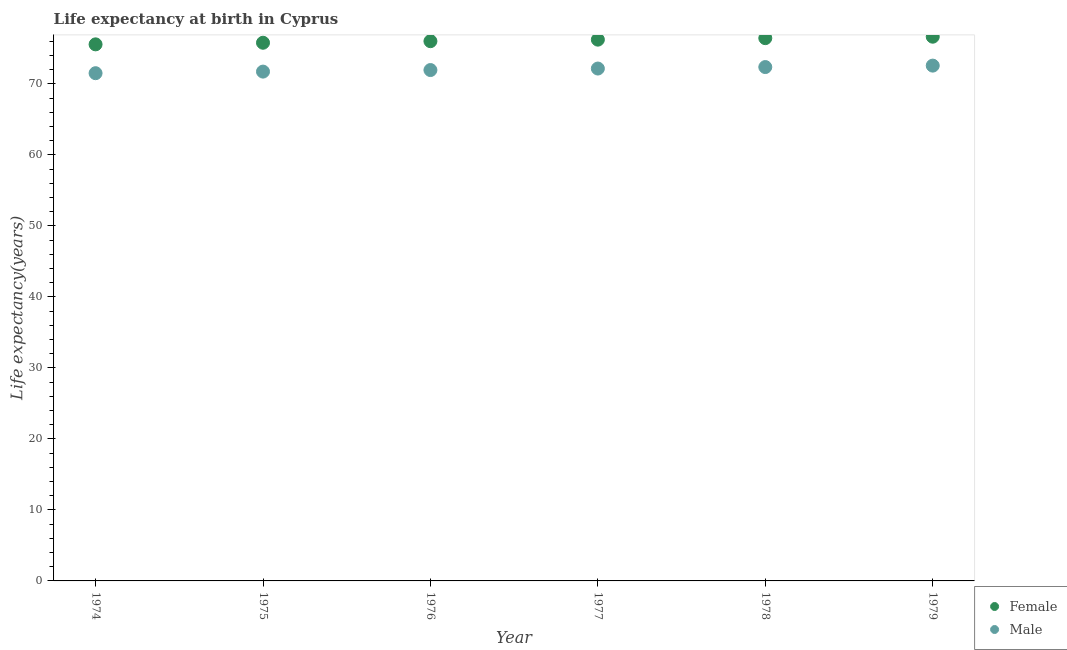What is the life expectancy(male) in 1977?
Give a very brief answer. 72.16. Across all years, what is the maximum life expectancy(male)?
Make the answer very short. 72.57. Across all years, what is the minimum life expectancy(female)?
Ensure brevity in your answer.  75.57. In which year was the life expectancy(female) maximum?
Offer a terse response. 1979. In which year was the life expectancy(male) minimum?
Make the answer very short. 1974. What is the total life expectancy(male) in the graph?
Offer a very short reply. 432.28. What is the difference between the life expectancy(male) in 1974 and that in 1978?
Offer a terse response. -0.86. What is the difference between the life expectancy(female) in 1975 and the life expectancy(male) in 1976?
Offer a terse response. 3.84. What is the average life expectancy(male) per year?
Give a very brief answer. 72.05. In the year 1978, what is the difference between the life expectancy(male) and life expectancy(female)?
Offer a very short reply. -4.07. In how many years, is the life expectancy(female) greater than 6 years?
Give a very brief answer. 6. What is the ratio of the life expectancy(female) in 1977 to that in 1978?
Keep it short and to the point. 1. Is the life expectancy(female) in 1977 less than that in 1979?
Give a very brief answer. Yes. Is the difference between the life expectancy(male) in 1974 and 1978 greater than the difference between the life expectancy(female) in 1974 and 1978?
Provide a short and direct response. Yes. What is the difference between the highest and the second highest life expectancy(female)?
Provide a short and direct response. 0.2. What is the difference between the highest and the lowest life expectancy(male)?
Your response must be concise. 1.07. In how many years, is the life expectancy(female) greater than the average life expectancy(female) taken over all years?
Give a very brief answer. 3. Is the sum of the life expectancy(female) in 1977 and 1978 greater than the maximum life expectancy(male) across all years?
Provide a succinct answer. Yes. What is the difference between two consecutive major ticks on the Y-axis?
Keep it short and to the point. 10. Are the values on the major ticks of Y-axis written in scientific E-notation?
Give a very brief answer. No. Does the graph contain any zero values?
Make the answer very short. No. How many legend labels are there?
Offer a terse response. 2. How are the legend labels stacked?
Your response must be concise. Vertical. What is the title of the graph?
Provide a short and direct response. Life expectancy at birth in Cyprus. Does "Secondary" appear as one of the legend labels in the graph?
Give a very brief answer. No. What is the label or title of the X-axis?
Keep it short and to the point. Year. What is the label or title of the Y-axis?
Keep it short and to the point. Life expectancy(years). What is the Life expectancy(years) in Female in 1974?
Your answer should be compact. 75.57. What is the Life expectancy(years) in Male in 1974?
Your response must be concise. 71.5. What is the Life expectancy(years) of Female in 1975?
Make the answer very short. 75.79. What is the Life expectancy(years) in Male in 1975?
Your response must be concise. 71.73. What is the Life expectancy(years) of Female in 1976?
Your answer should be very brief. 76.01. What is the Life expectancy(years) of Male in 1976?
Offer a terse response. 71.95. What is the Life expectancy(years) in Female in 1977?
Make the answer very short. 76.23. What is the Life expectancy(years) in Male in 1977?
Your answer should be compact. 72.16. What is the Life expectancy(years) of Female in 1978?
Make the answer very short. 76.44. What is the Life expectancy(years) of Male in 1978?
Your response must be concise. 72.37. What is the Life expectancy(years) of Female in 1979?
Your answer should be very brief. 76.64. What is the Life expectancy(years) in Male in 1979?
Provide a succinct answer. 72.57. Across all years, what is the maximum Life expectancy(years) in Female?
Offer a very short reply. 76.64. Across all years, what is the maximum Life expectancy(years) of Male?
Offer a terse response. 72.57. Across all years, what is the minimum Life expectancy(years) of Female?
Ensure brevity in your answer.  75.57. Across all years, what is the minimum Life expectancy(years) in Male?
Provide a short and direct response. 71.5. What is the total Life expectancy(years) in Female in the graph?
Give a very brief answer. 456.68. What is the total Life expectancy(years) in Male in the graph?
Your response must be concise. 432.28. What is the difference between the Life expectancy(years) of Female in 1974 and that in 1975?
Keep it short and to the point. -0.23. What is the difference between the Life expectancy(years) of Male in 1974 and that in 1975?
Your answer should be compact. -0.22. What is the difference between the Life expectancy(years) in Female in 1974 and that in 1976?
Your answer should be compact. -0.45. What is the difference between the Life expectancy(years) of Male in 1974 and that in 1976?
Offer a terse response. -0.44. What is the difference between the Life expectancy(years) in Female in 1974 and that in 1977?
Offer a terse response. -0.66. What is the difference between the Life expectancy(years) in Male in 1974 and that in 1977?
Make the answer very short. -0.66. What is the difference between the Life expectancy(years) in Female in 1974 and that in 1978?
Provide a short and direct response. -0.87. What is the difference between the Life expectancy(years) in Male in 1974 and that in 1978?
Provide a short and direct response. -0.86. What is the difference between the Life expectancy(years) in Female in 1974 and that in 1979?
Ensure brevity in your answer.  -1.08. What is the difference between the Life expectancy(years) of Male in 1974 and that in 1979?
Offer a terse response. -1.07. What is the difference between the Life expectancy(years) of Female in 1975 and that in 1976?
Your answer should be compact. -0.22. What is the difference between the Life expectancy(years) in Male in 1975 and that in 1976?
Provide a succinct answer. -0.22. What is the difference between the Life expectancy(years) of Female in 1975 and that in 1977?
Offer a very short reply. -0.44. What is the difference between the Life expectancy(years) of Male in 1975 and that in 1977?
Provide a short and direct response. -0.43. What is the difference between the Life expectancy(years) in Female in 1975 and that in 1978?
Make the answer very short. -0.65. What is the difference between the Life expectancy(years) of Male in 1975 and that in 1978?
Offer a very short reply. -0.64. What is the difference between the Life expectancy(years) of Female in 1975 and that in 1979?
Ensure brevity in your answer.  -0.85. What is the difference between the Life expectancy(years) of Male in 1975 and that in 1979?
Make the answer very short. -0.84. What is the difference between the Life expectancy(years) in Female in 1976 and that in 1977?
Provide a short and direct response. -0.22. What is the difference between the Life expectancy(years) in Male in 1976 and that in 1977?
Make the answer very short. -0.21. What is the difference between the Life expectancy(years) in Female in 1976 and that in 1978?
Make the answer very short. -0.43. What is the difference between the Life expectancy(years) in Male in 1976 and that in 1978?
Offer a terse response. -0.42. What is the difference between the Life expectancy(years) of Female in 1976 and that in 1979?
Offer a very short reply. -0.63. What is the difference between the Life expectancy(years) of Male in 1976 and that in 1979?
Offer a terse response. -0.62. What is the difference between the Life expectancy(years) in Female in 1977 and that in 1978?
Ensure brevity in your answer.  -0.21. What is the difference between the Life expectancy(years) in Male in 1977 and that in 1978?
Give a very brief answer. -0.21. What is the difference between the Life expectancy(years) of Female in 1977 and that in 1979?
Keep it short and to the point. -0.41. What is the difference between the Life expectancy(years) of Male in 1977 and that in 1979?
Provide a short and direct response. -0.41. What is the difference between the Life expectancy(years) of Female in 1978 and that in 1979?
Offer a terse response. -0.2. What is the difference between the Life expectancy(years) of Male in 1978 and that in 1979?
Provide a succinct answer. -0.2. What is the difference between the Life expectancy(years) in Female in 1974 and the Life expectancy(years) in Male in 1975?
Provide a succinct answer. 3.84. What is the difference between the Life expectancy(years) in Female in 1974 and the Life expectancy(years) in Male in 1976?
Give a very brief answer. 3.62. What is the difference between the Life expectancy(years) of Female in 1974 and the Life expectancy(years) of Male in 1977?
Provide a succinct answer. 3.41. What is the difference between the Life expectancy(years) in Female in 1974 and the Life expectancy(years) in Male in 1978?
Your answer should be very brief. 3.2. What is the difference between the Life expectancy(years) in Female in 1974 and the Life expectancy(years) in Male in 1979?
Ensure brevity in your answer.  3. What is the difference between the Life expectancy(years) of Female in 1975 and the Life expectancy(years) of Male in 1976?
Give a very brief answer. 3.85. What is the difference between the Life expectancy(years) in Female in 1975 and the Life expectancy(years) in Male in 1977?
Give a very brief answer. 3.63. What is the difference between the Life expectancy(years) in Female in 1975 and the Life expectancy(years) in Male in 1978?
Your response must be concise. 3.42. What is the difference between the Life expectancy(years) in Female in 1975 and the Life expectancy(years) in Male in 1979?
Provide a succinct answer. 3.22. What is the difference between the Life expectancy(years) in Female in 1976 and the Life expectancy(years) in Male in 1977?
Provide a short and direct response. 3.85. What is the difference between the Life expectancy(years) of Female in 1976 and the Life expectancy(years) of Male in 1978?
Make the answer very short. 3.65. What is the difference between the Life expectancy(years) in Female in 1976 and the Life expectancy(years) in Male in 1979?
Offer a terse response. 3.44. What is the difference between the Life expectancy(years) of Female in 1977 and the Life expectancy(years) of Male in 1978?
Offer a terse response. 3.86. What is the difference between the Life expectancy(years) in Female in 1977 and the Life expectancy(years) in Male in 1979?
Give a very brief answer. 3.66. What is the difference between the Life expectancy(years) of Female in 1978 and the Life expectancy(years) of Male in 1979?
Provide a succinct answer. 3.87. What is the average Life expectancy(years) in Female per year?
Provide a short and direct response. 76.11. What is the average Life expectancy(years) in Male per year?
Provide a short and direct response. 72.05. In the year 1974, what is the difference between the Life expectancy(years) in Female and Life expectancy(years) in Male?
Offer a terse response. 4.06. In the year 1975, what is the difference between the Life expectancy(years) of Female and Life expectancy(years) of Male?
Provide a succinct answer. 4.06. In the year 1976, what is the difference between the Life expectancy(years) of Female and Life expectancy(years) of Male?
Make the answer very short. 4.07. In the year 1977, what is the difference between the Life expectancy(years) in Female and Life expectancy(years) in Male?
Give a very brief answer. 4.07. In the year 1978, what is the difference between the Life expectancy(years) of Female and Life expectancy(years) of Male?
Make the answer very short. 4.07. In the year 1979, what is the difference between the Life expectancy(years) in Female and Life expectancy(years) in Male?
Make the answer very short. 4.07. What is the ratio of the Life expectancy(years) of Female in 1974 to that in 1975?
Your answer should be compact. 1. What is the ratio of the Life expectancy(years) of Female in 1974 to that in 1977?
Provide a short and direct response. 0.99. What is the ratio of the Life expectancy(years) of Male in 1974 to that in 1977?
Your answer should be compact. 0.99. What is the ratio of the Life expectancy(years) of Female in 1974 to that in 1978?
Keep it short and to the point. 0.99. What is the ratio of the Life expectancy(years) in Male in 1974 to that in 1978?
Offer a very short reply. 0.99. What is the ratio of the Life expectancy(years) of Female in 1974 to that in 1979?
Keep it short and to the point. 0.99. What is the ratio of the Life expectancy(years) in Female in 1975 to that in 1976?
Make the answer very short. 1. What is the ratio of the Life expectancy(years) of Male in 1975 to that in 1977?
Give a very brief answer. 0.99. What is the ratio of the Life expectancy(years) of Female in 1975 to that in 1978?
Your answer should be compact. 0.99. What is the ratio of the Life expectancy(years) of Male in 1975 to that in 1978?
Give a very brief answer. 0.99. What is the ratio of the Life expectancy(years) in Female in 1975 to that in 1979?
Your answer should be compact. 0.99. What is the ratio of the Life expectancy(years) in Male in 1975 to that in 1979?
Your answer should be very brief. 0.99. What is the ratio of the Life expectancy(years) in Female in 1976 to that in 1978?
Ensure brevity in your answer.  0.99. What is the ratio of the Life expectancy(years) in Male in 1976 to that in 1978?
Make the answer very short. 0.99. What is the ratio of the Life expectancy(years) in Male in 1976 to that in 1979?
Give a very brief answer. 0.99. What is the ratio of the Life expectancy(years) of Female in 1977 to that in 1979?
Keep it short and to the point. 0.99. What is the ratio of the Life expectancy(years) in Male in 1978 to that in 1979?
Offer a very short reply. 1. What is the difference between the highest and the second highest Life expectancy(years) in Female?
Keep it short and to the point. 0.2. What is the difference between the highest and the second highest Life expectancy(years) in Male?
Ensure brevity in your answer.  0.2. What is the difference between the highest and the lowest Life expectancy(years) of Female?
Your answer should be compact. 1.08. What is the difference between the highest and the lowest Life expectancy(years) in Male?
Your response must be concise. 1.07. 